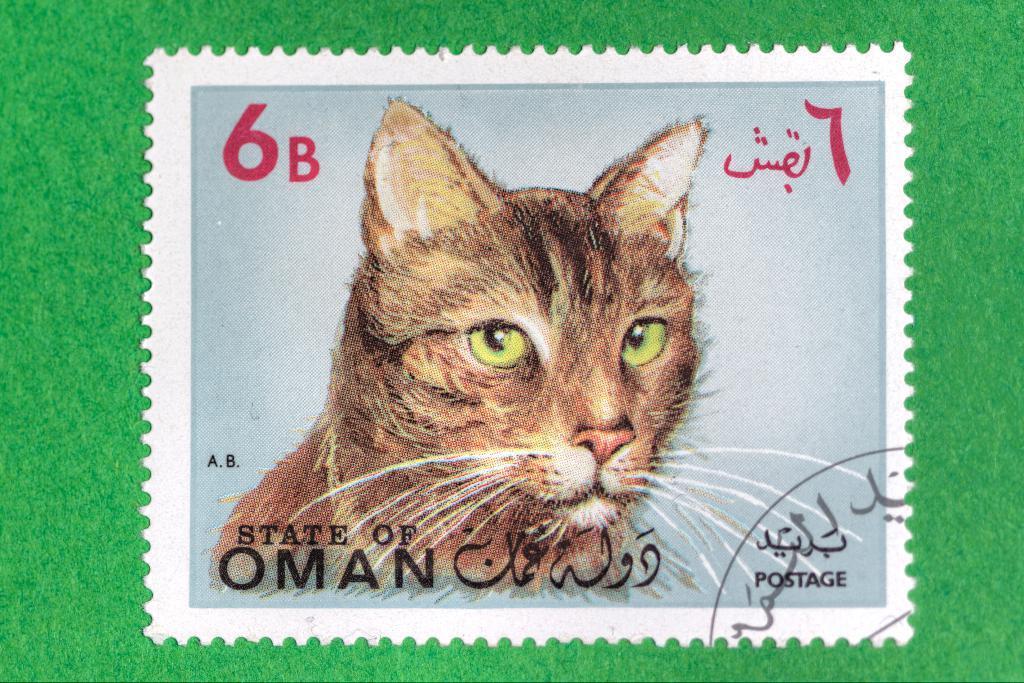Could you give a brief overview of what you see in this image? In this image I can see the postage stamp on the green color surface. On the stamp I can see the cat and something is written. 